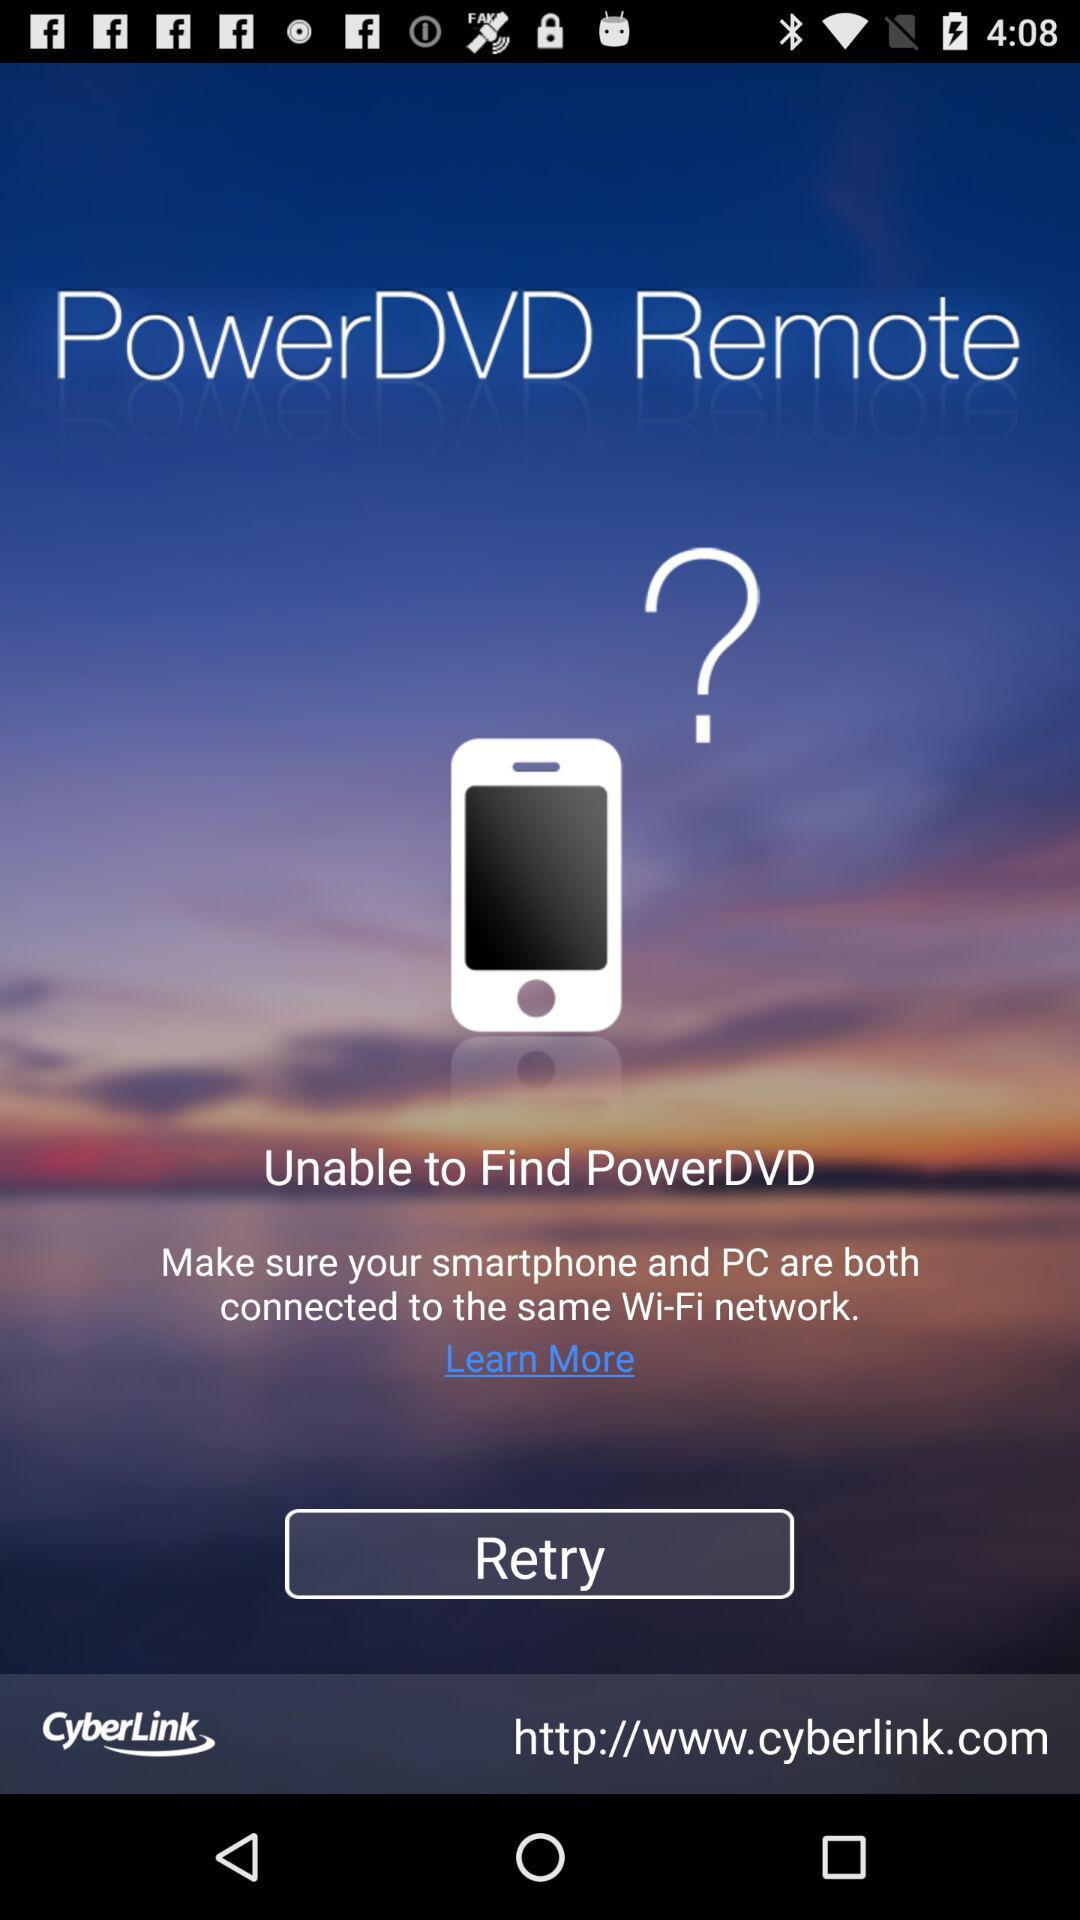What is the application name? The application name is "PowerDVD Remote". 